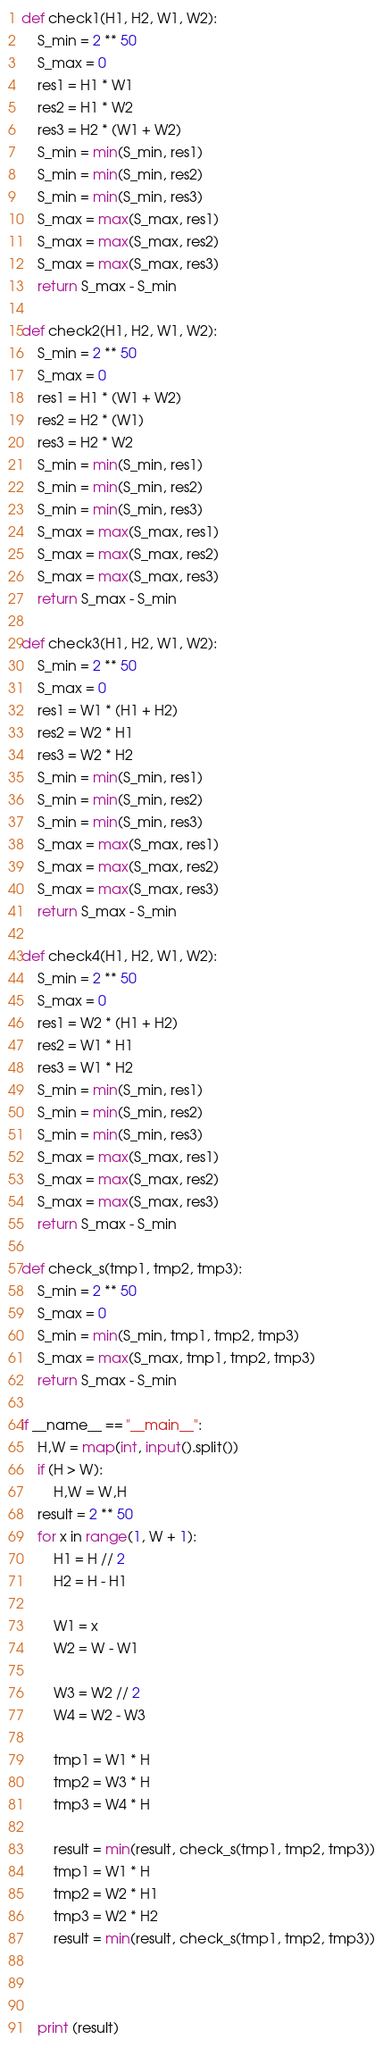<code> <loc_0><loc_0><loc_500><loc_500><_Python_>def check1(H1, H2, W1, W2):
    S_min = 2 ** 50
    S_max = 0
    res1 = H1 * W1
    res2 = H1 * W2
    res3 = H2 * (W1 + W2)
    S_min = min(S_min, res1)
    S_min = min(S_min, res2)
    S_min = min(S_min, res3)
    S_max = max(S_max, res1)
    S_max = max(S_max, res2)
    S_max = max(S_max, res3)
    return S_max - S_min

def check2(H1, H2, W1, W2):
    S_min = 2 ** 50
    S_max = 0
    res1 = H1 * (W1 + W2)
    res2 = H2 * (W1)
    res3 = H2 * W2
    S_min = min(S_min, res1)
    S_min = min(S_min, res2)
    S_min = min(S_min, res3)
    S_max = max(S_max, res1)
    S_max = max(S_max, res2)
    S_max = max(S_max, res3)
    return S_max - S_min

def check3(H1, H2, W1, W2):
    S_min = 2 ** 50
    S_max = 0
    res1 = W1 * (H1 + H2)
    res2 = W2 * H1
    res3 = W2 * H2
    S_min = min(S_min, res1)
    S_min = min(S_min, res2)
    S_min = min(S_min, res3)
    S_max = max(S_max, res1)
    S_max = max(S_max, res2)
    S_max = max(S_max, res3)
    return S_max - S_min

def check4(H1, H2, W1, W2):
    S_min = 2 ** 50
    S_max = 0
    res1 = W2 * (H1 + H2)
    res2 = W1 * H1
    res3 = W1 * H2
    S_min = min(S_min, res1)
    S_min = min(S_min, res2)
    S_min = min(S_min, res3)
    S_max = max(S_max, res1)
    S_max = max(S_max, res2)
    S_max = max(S_max, res3)
    return S_max - S_min

def check_s(tmp1, tmp2, tmp3):
    S_min = 2 ** 50
    S_max = 0
    S_min = min(S_min, tmp1, tmp2, tmp3)
    S_max = max(S_max, tmp1, tmp2, tmp3)
    return S_max - S_min

if __name__ == "__main__":
    H,W = map(int, input().split())
    if (H > W):
        H,W = W,H
    result = 2 ** 50
    for x in range(1, W + 1):
        H1 = H // 2
        H2 = H - H1

        W1 = x
        W2 = W - W1

        W3 = W2 // 2
        W4 = W2 - W3

        tmp1 = W1 * H
        tmp2 = W3 * H
        tmp3 = W4 * H

        result = min(result, check_s(tmp1, tmp2, tmp3))
        tmp1 = W1 * H
        tmp2 = W2 * H1
        tmp3 = W2 * H2
        result = min(result, check_s(tmp1, tmp2, tmp3))

    

    print (result)
</code> 